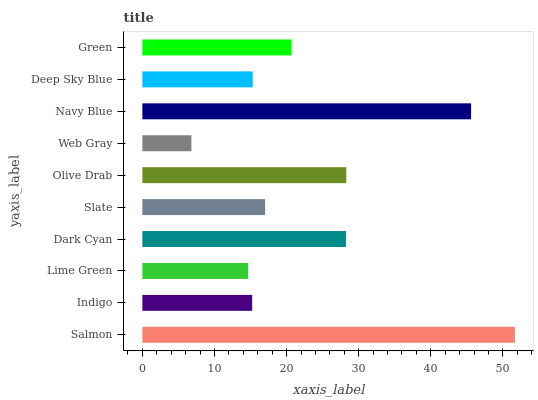Is Web Gray the minimum?
Answer yes or no. Yes. Is Salmon the maximum?
Answer yes or no. Yes. Is Indigo the minimum?
Answer yes or no. No. Is Indigo the maximum?
Answer yes or no. No. Is Salmon greater than Indigo?
Answer yes or no. Yes. Is Indigo less than Salmon?
Answer yes or no. Yes. Is Indigo greater than Salmon?
Answer yes or no. No. Is Salmon less than Indigo?
Answer yes or no. No. Is Green the high median?
Answer yes or no. Yes. Is Slate the low median?
Answer yes or no. Yes. Is Deep Sky Blue the high median?
Answer yes or no. No. Is Olive Drab the low median?
Answer yes or no. No. 